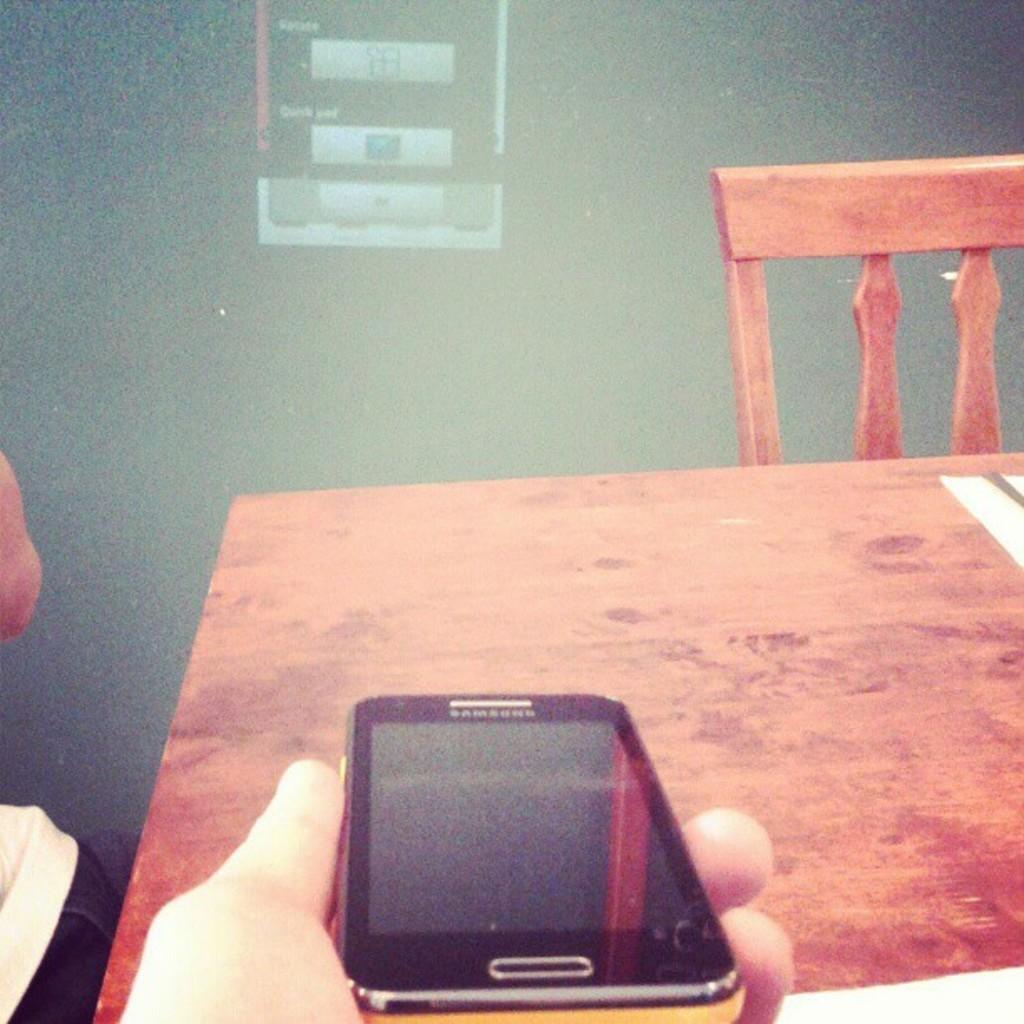Can you describe this image briefly? This is the picture taken in a room, a person is holding a Samsung mobile in front of the mobile there is a wooden table and a chair. Behind the table there is a screen. 